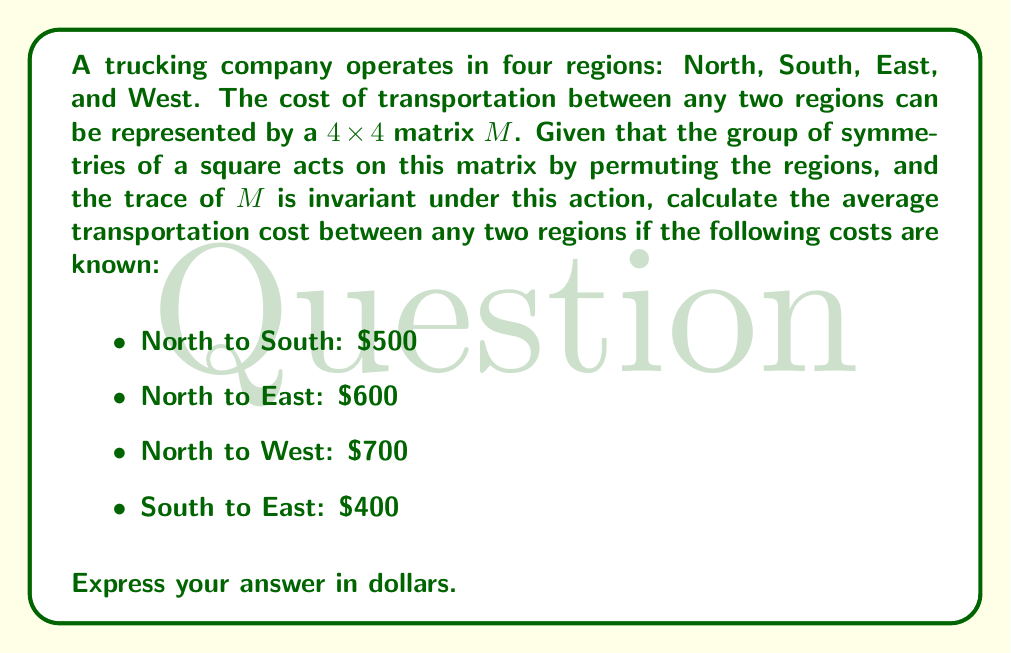What is the answer to this math problem? Let's approach this step-by-step:

1) The group of symmetries of a square is the dihedral group $D_4$, which has 8 elements. These symmetries correspond to the ways we can permute the four regions while preserving the structure of the cost matrix.

2) The trace of the matrix $M$ is invariant under the action of $D_4$. This means that the sum of the diagonal elements (which represent the cost of transportation within each region, typically $0$) remains constant.

3) Due to the symmetry, we can deduce that:
   - South to North = North to South = $\$500$
   - East to North = North to East = $\$600$
   - West to North = North to West = $\$700$
   - East to South = South to East = $\$400$

4) We're missing information about South to West and East to West. Let's call these unknown costs $x$ and $y$ respectively.

5) The matrix $M$ would look like this:

   $$M = \begin{pmatrix}
   0 & 500 & 600 & 700 \\
   500 & 0 & 400 & x \\
   600 & 400 & 0 & y \\
   700 & x & y & 0
   \end{pmatrix}$$

6) Due to the symmetry, we know that $x = y$.

7) The total of all costs in the matrix is equal to twice the sum of all unique costs (as each cost appears twice in the matrix, once in each direction).

8) So, the sum of all unique costs is:
   $$(500 + 600 + 700 + 400 + x) = \frac{1}{2}(500 + 600 + 700 + 400 + 500 + 600 + 700 + 400 + x + x)$$

9) The average cost is this sum divided by the number of unique costs (6):
   $$\text{Average} = \frac{500 + 600 + 700 + 400 + x}{6}$$

10) We don't need to know the value of $x$ to calculate this average, as it represents the remaining unknown cost.

11) Calculate:
    $$\text{Average} = \frac{2200 + x}{6} = \frac{2200}{6} + \frac{x}{6} = 366.\overline{6} + \frac{x}{6}$$

12) The average of all costs, including $x$, must equal the average of the known costs:
    $$366.\overline{6} + \frac{x}{6} = \frac{500 + 600 + 700 + 400}{4} = 550$$

13) Solving this equation:
    $$366.\overline{6} + \frac{x}{6} = 550$$
    $$\frac{x}{6} = 183.\overline{3}$$
    $$x = 1100$$

14) Therefore, the average cost is $\$550$.
Answer: $550 